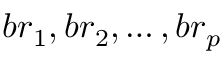<formula> <loc_0><loc_0><loc_500><loc_500>{ b r _ { 1 } , b r _ { 2 } , \dots , b r _ { p } }</formula> 